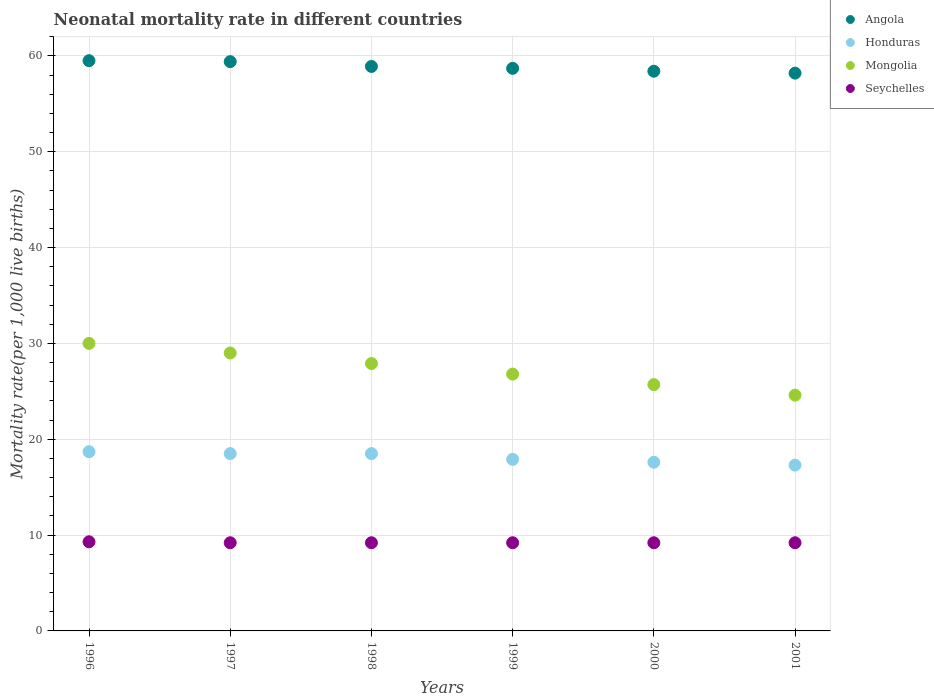What is the neonatal mortality rate in Mongolia in 2001?
Offer a terse response. 24.6. Across all years, what is the maximum neonatal mortality rate in Seychelles?
Give a very brief answer. 9.3. In which year was the neonatal mortality rate in Seychelles minimum?
Your answer should be very brief. 1997. What is the total neonatal mortality rate in Angola in the graph?
Offer a very short reply. 353.1. What is the difference between the neonatal mortality rate in Seychelles in 1996 and that in 1998?
Offer a very short reply. 0.1. What is the average neonatal mortality rate in Angola per year?
Offer a terse response. 58.85. In the year 1996, what is the difference between the neonatal mortality rate in Seychelles and neonatal mortality rate in Honduras?
Make the answer very short. -9.4. In how many years, is the neonatal mortality rate in Honduras greater than 6?
Your response must be concise. 6. What is the ratio of the neonatal mortality rate in Seychelles in 1997 to that in 1998?
Your answer should be very brief. 1. Is the neonatal mortality rate in Angola in 1997 less than that in 2000?
Your answer should be very brief. No. Is the difference between the neonatal mortality rate in Seychelles in 1997 and 1999 greater than the difference between the neonatal mortality rate in Honduras in 1997 and 1999?
Keep it short and to the point. No. What is the difference between the highest and the second highest neonatal mortality rate in Seychelles?
Offer a terse response. 0.1. What is the difference between the highest and the lowest neonatal mortality rate in Honduras?
Your answer should be very brief. 1.4. Is the sum of the neonatal mortality rate in Angola in 1998 and 2000 greater than the maximum neonatal mortality rate in Honduras across all years?
Keep it short and to the point. Yes. Is it the case that in every year, the sum of the neonatal mortality rate in Honduras and neonatal mortality rate in Mongolia  is greater than the sum of neonatal mortality rate in Seychelles and neonatal mortality rate in Angola?
Offer a very short reply. Yes. How many years are there in the graph?
Offer a very short reply. 6. What is the difference between two consecutive major ticks on the Y-axis?
Give a very brief answer. 10. Are the values on the major ticks of Y-axis written in scientific E-notation?
Keep it short and to the point. No. Where does the legend appear in the graph?
Your answer should be very brief. Top right. How many legend labels are there?
Give a very brief answer. 4. How are the legend labels stacked?
Make the answer very short. Vertical. What is the title of the graph?
Your answer should be compact. Neonatal mortality rate in different countries. What is the label or title of the Y-axis?
Your answer should be compact. Mortality rate(per 1,0 live births). What is the Mortality rate(per 1,000 live births) in Angola in 1996?
Provide a short and direct response. 59.5. What is the Mortality rate(per 1,000 live births) of Seychelles in 1996?
Ensure brevity in your answer.  9.3. What is the Mortality rate(per 1,000 live births) in Angola in 1997?
Give a very brief answer. 59.4. What is the Mortality rate(per 1,000 live births) in Honduras in 1997?
Make the answer very short. 18.5. What is the Mortality rate(per 1,000 live births) in Angola in 1998?
Offer a very short reply. 58.9. What is the Mortality rate(per 1,000 live births) of Mongolia in 1998?
Offer a very short reply. 27.9. What is the Mortality rate(per 1,000 live births) of Angola in 1999?
Provide a short and direct response. 58.7. What is the Mortality rate(per 1,000 live births) of Mongolia in 1999?
Your answer should be very brief. 26.8. What is the Mortality rate(per 1,000 live births) of Angola in 2000?
Your response must be concise. 58.4. What is the Mortality rate(per 1,000 live births) of Honduras in 2000?
Offer a terse response. 17.6. What is the Mortality rate(per 1,000 live births) in Mongolia in 2000?
Keep it short and to the point. 25.7. What is the Mortality rate(per 1,000 live births) in Angola in 2001?
Ensure brevity in your answer.  58.2. What is the Mortality rate(per 1,000 live births) in Mongolia in 2001?
Ensure brevity in your answer.  24.6. Across all years, what is the maximum Mortality rate(per 1,000 live births) in Angola?
Make the answer very short. 59.5. Across all years, what is the maximum Mortality rate(per 1,000 live births) of Honduras?
Make the answer very short. 18.7. Across all years, what is the minimum Mortality rate(per 1,000 live births) of Angola?
Offer a terse response. 58.2. Across all years, what is the minimum Mortality rate(per 1,000 live births) in Mongolia?
Provide a short and direct response. 24.6. What is the total Mortality rate(per 1,000 live births) in Angola in the graph?
Provide a succinct answer. 353.1. What is the total Mortality rate(per 1,000 live births) in Honduras in the graph?
Ensure brevity in your answer.  108.5. What is the total Mortality rate(per 1,000 live births) of Mongolia in the graph?
Ensure brevity in your answer.  164. What is the total Mortality rate(per 1,000 live births) in Seychelles in the graph?
Offer a very short reply. 55.3. What is the difference between the Mortality rate(per 1,000 live births) of Honduras in 1996 and that in 1997?
Give a very brief answer. 0.2. What is the difference between the Mortality rate(per 1,000 live births) of Seychelles in 1996 and that in 1997?
Provide a short and direct response. 0.1. What is the difference between the Mortality rate(per 1,000 live births) of Mongolia in 1996 and that in 1998?
Your answer should be very brief. 2.1. What is the difference between the Mortality rate(per 1,000 live births) in Seychelles in 1996 and that in 1998?
Ensure brevity in your answer.  0.1. What is the difference between the Mortality rate(per 1,000 live births) of Seychelles in 1996 and that in 1999?
Provide a short and direct response. 0.1. What is the difference between the Mortality rate(per 1,000 live births) in Honduras in 1996 and that in 2000?
Keep it short and to the point. 1.1. What is the difference between the Mortality rate(per 1,000 live births) of Honduras in 1996 and that in 2001?
Offer a very short reply. 1.4. What is the difference between the Mortality rate(per 1,000 live births) of Mongolia in 1996 and that in 2001?
Provide a short and direct response. 5.4. What is the difference between the Mortality rate(per 1,000 live births) of Mongolia in 1997 and that in 1998?
Ensure brevity in your answer.  1.1. What is the difference between the Mortality rate(per 1,000 live births) of Honduras in 1997 and that in 1999?
Your answer should be very brief. 0.6. What is the difference between the Mortality rate(per 1,000 live births) in Mongolia in 1997 and that in 1999?
Provide a short and direct response. 2.2. What is the difference between the Mortality rate(per 1,000 live births) of Angola in 1997 and that in 2000?
Make the answer very short. 1. What is the difference between the Mortality rate(per 1,000 live births) of Mongolia in 1997 and that in 2000?
Ensure brevity in your answer.  3.3. What is the difference between the Mortality rate(per 1,000 live births) in Angola in 1997 and that in 2001?
Your answer should be compact. 1.2. What is the difference between the Mortality rate(per 1,000 live births) of Mongolia in 1998 and that in 1999?
Offer a terse response. 1.1. What is the difference between the Mortality rate(per 1,000 live births) of Seychelles in 1998 and that in 1999?
Ensure brevity in your answer.  0. What is the difference between the Mortality rate(per 1,000 live births) of Mongolia in 1998 and that in 2000?
Ensure brevity in your answer.  2.2. What is the difference between the Mortality rate(per 1,000 live births) in Honduras in 1998 and that in 2001?
Make the answer very short. 1.2. What is the difference between the Mortality rate(per 1,000 live births) of Mongolia in 1998 and that in 2001?
Keep it short and to the point. 3.3. What is the difference between the Mortality rate(per 1,000 live births) of Seychelles in 1999 and that in 2000?
Ensure brevity in your answer.  0. What is the difference between the Mortality rate(per 1,000 live births) in Angola in 1999 and that in 2001?
Keep it short and to the point. 0.5. What is the difference between the Mortality rate(per 1,000 live births) in Honduras in 1999 and that in 2001?
Make the answer very short. 0.6. What is the difference between the Mortality rate(per 1,000 live births) in Seychelles in 1999 and that in 2001?
Keep it short and to the point. 0. What is the difference between the Mortality rate(per 1,000 live births) of Mongolia in 2000 and that in 2001?
Provide a succinct answer. 1.1. What is the difference between the Mortality rate(per 1,000 live births) in Angola in 1996 and the Mortality rate(per 1,000 live births) in Mongolia in 1997?
Keep it short and to the point. 30.5. What is the difference between the Mortality rate(per 1,000 live births) in Angola in 1996 and the Mortality rate(per 1,000 live births) in Seychelles in 1997?
Make the answer very short. 50.3. What is the difference between the Mortality rate(per 1,000 live births) of Mongolia in 1996 and the Mortality rate(per 1,000 live births) of Seychelles in 1997?
Offer a very short reply. 20.8. What is the difference between the Mortality rate(per 1,000 live births) in Angola in 1996 and the Mortality rate(per 1,000 live births) in Honduras in 1998?
Offer a very short reply. 41. What is the difference between the Mortality rate(per 1,000 live births) of Angola in 1996 and the Mortality rate(per 1,000 live births) of Mongolia in 1998?
Provide a short and direct response. 31.6. What is the difference between the Mortality rate(per 1,000 live births) of Angola in 1996 and the Mortality rate(per 1,000 live births) of Seychelles in 1998?
Provide a short and direct response. 50.3. What is the difference between the Mortality rate(per 1,000 live births) in Honduras in 1996 and the Mortality rate(per 1,000 live births) in Mongolia in 1998?
Your answer should be very brief. -9.2. What is the difference between the Mortality rate(per 1,000 live births) in Honduras in 1996 and the Mortality rate(per 1,000 live births) in Seychelles in 1998?
Your answer should be compact. 9.5. What is the difference between the Mortality rate(per 1,000 live births) in Mongolia in 1996 and the Mortality rate(per 1,000 live births) in Seychelles in 1998?
Offer a very short reply. 20.8. What is the difference between the Mortality rate(per 1,000 live births) in Angola in 1996 and the Mortality rate(per 1,000 live births) in Honduras in 1999?
Your answer should be compact. 41.6. What is the difference between the Mortality rate(per 1,000 live births) in Angola in 1996 and the Mortality rate(per 1,000 live births) in Mongolia in 1999?
Offer a very short reply. 32.7. What is the difference between the Mortality rate(per 1,000 live births) in Angola in 1996 and the Mortality rate(per 1,000 live births) in Seychelles in 1999?
Provide a succinct answer. 50.3. What is the difference between the Mortality rate(per 1,000 live births) of Honduras in 1996 and the Mortality rate(per 1,000 live births) of Mongolia in 1999?
Offer a very short reply. -8.1. What is the difference between the Mortality rate(per 1,000 live births) in Mongolia in 1996 and the Mortality rate(per 1,000 live births) in Seychelles in 1999?
Your answer should be compact. 20.8. What is the difference between the Mortality rate(per 1,000 live births) in Angola in 1996 and the Mortality rate(per 1,000 live births) in Honduras in 2000?
Provide a short and direct response. 41.9. What is the difference between the Mortality rate(per 1,000 live births) in Angola in 1996 and the Mortality rate(per 1,000 live births) in Mongolia in 2000?
Your response must be concise. 33.8. What is the difference between the Mortality rate(per 1,000 live births) of Angola in 1996 and the Mortality rate(per 1,000 live births) of Seychelles in 2000?
Offer a terse response. 50.3. What is the difference between the Mortality rate(per 1,000 live births) of Mongolia in 1996 and the Mortality rate(per 1,000 live births) of Seychelles in 2000?
Make the answer very short. 20.8. What is the difference between the Mortality rate(per 1,000 live births) in Angola in 1996 and the Mortality rate(per 1,000 live births) in Honduras in 2001?
Offer a terse response. 42.2. What is the difference between the Mortality rate(per 1,000 live births) in Angola in 1996 and the Mortality rate(per 1,000 live births) in Mongolia in 2001?
Offer a very short reply. 34.9. What is the difference between the Mortality rate(per 1,000 live births) in Angola in 1996 and the Mortality rate(per 1,000 live births) in Seychelles in 2001?
Give a very brief answer. 50.3. What is the difference between the Mortality rate(per 1,000 live births) in Honduras in 1996 and the Mortality rate(per 1,000 live births) in Seychelles in 2001?
Provide a succinct answer. 9.5. What is the difference between the Mortality rate(per 1,000 live births) of Mongolia in 1996 and the Mortality rate(per 1,000 live births) of Seychelles in 2001?
Provide a succinct answer. 20.8. What is the difference between the Mortality rate(per 1,000 live births) of Angola in 1997 and the Mortality rate(per 1,000 live births) of Honduras in 1998?
Make the answer very short. 40.9. What is the difference between the Mortality rate(per 1,000 live births) of Angola in 1997 and the Mortality rate(per 1,000 live births) of Mongolia in 1998?
Your answer should be very brief. 31.5. What is the difference between the Mortality rate(per 1,000 live births) in Angola in 1997 and the Mortality rate(per 1,000 live births) in Seychelles in 1998?
Your answer should be very brief. 50.2. What is the difference between the Mortality rate(per 1,000 live births) of Honduras in 1997 and the Mortality rate(per 1,000 live births) of Mongolia in 1998?
Give a very brief answer. -9.4. What is the difference between the Mortality rate(per 1,000 live births) of Mongolia in 1997 and the Mortality rate(per 1,000 live births) of Seychelles in 1998?
Ensure brevity in your answer.  19.8. What is the difference between the Mortality rate(per 1,000 live births) of Angola in 1997 and the Mortality rate(per 1,000 live births) of Honduras in 1999?
Your response must be concise. 41.5. What is the difference between the Mortality rate(per 1,000 live births) in Angola in 1997 and the Mortality rate(per 1,000 live births) in Mongolia in 1999?
Your answer should be very brief. 32.6. What is the difference between the Mortality rate(per 1,000 live births) in Angola in 1997 and the Mortality rate(per 1,000 live births) in Seychelles in 1999?
Ensure brevity in your answer.  50.2. What is the difference between the Mortality rate(per 1,000 live births) in Honduras in 1997 and the Mortality rate(per 1,000 live births) in Mongolia in 1999?
Your response must be concise. -8.3. What is the difference between the Mortality rate(per 1,000 live births) in Honduras in 1997 and the Mortality rate(per 1,000 live births) in Seychelles in 1999?
Provide a succinct answer. 9.3. What is the difference between the Mortality rate(per 1,000 live births) in Mongolia in 1997 and the Mortality rate(per 1,000 live births) in Seychelles in 1999?
Provide a succinct answer. 19.8. What is the difference between the Mortality rate(per 1,000 live births) of Angola in 1997 and the Mortality rate(per 1,000 live births) of Honduras in 2000?
Offer a very short reply. 41.8. What is the difference between the Mortality rate(per 1,000 live births) of Angola in 1997 and the Mortality rate(per 1,000 live births) of Mongolia in 2000?
Provide a succinct answer. 33.7. What is the difference between the Mortality rate(per 1,000 live births) in Angola in 1997 and the Mortality rate(per 1,000 live births) in Seychelles in 2000?
Give a very brief answer. 50.2. What is the difference between the Mortality rate(per 1,000 live births) in Mongolia in 1997 and the Mortality rate(per 1,000 live births) in Seychelles in 2000?
Offer a terse response. 19.8. What is the difference between the Mortality rate(per 1,000 live births) in Angola in 1997 and the Mortality rate(per 1,000 live births) in Honduras in 2001?
Provide a short and direct response. 42.1. What is the difference between the Mortality rate(per 1,000 live births) of Angola in 1997 and the Mortality rate(per 1,000 live births) of Mongolia in 2001?
Provide a short and direct response. 34.8. What is the difference between the Mortality rate(per 1,000 live births) of Angola in 1997 and the Mortality rate(per 1,000 live births) of Seychelles in 2001?
Make the answer very short. 50.2. What is the difference between the Mortality rate(per 1,000 live births) of Honduras in 1997 and the Mortality rate(per 1,000 live births) of Mongolia in 2001?
Give a very brief answer. -6.1. What is the difference between the Mortality rate(per 1,000 live births) of Mongolia in 1997 and the Mortality rate(per 1,000 live births) of Seychelles in 2001?
Your answer should be very brief. 19.8. What is the difference between the Mortality rate(per 1,000 live births) in Angola in 1998 and the Mortality rate(per 1,000 live births) in Honduras in 1999?
Give a very brief answer. 41. What is the difference between the Mortality rate(per 1,000 live births) in Angola in 1998 and the Mortality rate(per 1,000 live births) in Mongolia in 1999?
Offer a terse response. 32.1. What is the difference between the Mortality rate(per 1,000 live births) in Angola in 1998 and the Mortality rate(per 1,000 live births) in Seychelles in 1999?
Make the answer very short. 49.7. What is the difference between the Mortality rate(per 1,000 live births) in Honduras in 1998 and the Mortality rate(per 1,000 live births) in Mongolia in 1999?
Ensure brevity in your answer.  -8.3. What is the difference between the Mortality rate(per 1,000 live births) in Honduras in 1998 and the Mortality rate(per 1,000 live births) in Seychelles in 1999?
Offer a terse response. 9.3. What is the difference between the Mortality rate(per 1,000 live births) of Angola in 1998 and the Mortality rate(per 1,000 live births) of Honduras in 2000?
Ensure brevity in your answer.  41.3. What is the difference between the Mortality rate(per 1,000 live births) of Angola in 1998 and the Mortality rate(per 1,000 live births) of Mongolia in 2000?
Ensure brevity in your answer.  33.2. What is the difference between the Mortality rate(per 1,000 live births) of Angola in 1998 and the Mortality rate(per 1,000 live births) of Seychelles in 2000?
Offer a terse response. 49.7. What is the difference between the Mortality rate(per 1,000 live births) in Honduras in 1998 and the Mortality rate(per 1,000 live births) in Seychelles in 2000?
Offer a terse response. 9.3. What is the difference between the Mortality rate(per 1,000 live births) of Mongolia in 1998 and the Mortality rate(per 1,000 live births) of Seychelles in 2000?
Ensure brevity in your answer.  18.7. What is the difference between the Mortality rate(per 1,000 live births) in Angola in 1998 and the Mortality rate(per 1,000 live births) in Honduras in 2001?
Ensure brevity in your answer.  41.6. What is the difference between the Mortality rate(per 1,000 live births) in Angola in 1998 and the Mortality rate(per 1,000 live births) in Mongolia in 2001?
Your response must be concise. 34.3. What is the difference between the Mortality rate(per 1,000 live births) of Angola in 1998 and the Mortality rate(per 1,000 live births) of Seychelles in 2001?
Make the answer very short. 49.7. What is the difference between the Mortality rate(per 1,000 live births) in Honduras in 1998 and the Mortality rate(per 1,000 live births) in Mongolia in 2001?
Offer a terse response. -6.1. What is the difference between the Mortality rate(per 1,000 live births) in Honduras in 1998 and the Mortality rate(per 1,000 live births) in Seychelles in 2001?
Provide a short and direct response. 9.3. What is the difference between the Mortality rate(per 1,000 live births) of Mongolia in 1998 and the Mortality rate(per 1,000 live births) of Seychelles in 2001?
Your answer should be very brief. 18.7. What is the difference between the Mortality rate(per 1,000 live births) in Angola in 1999 and the Mortality rate(per 1,000 live births) in Honduras in 2000?
Your answer should be very brief. 41.1. What is the difference between the Mortality rate(per 1,000 live births) of Angola in 1999 and the Mortality rate(per 1,000 live births) of Mongolia in 2000?
Provide a succinct answer. 33. What is the difference between the Mortality rate(per 1,000 live births) of Angola in 1999 and the Mortality rate(per 1,000 live births) of Seychelles in 2000?
Your answer should be very brief. 49.5. What is the difference between the Mortality rate(per 1,000 live births) of Honduras in 1999 and the Mortality rate(per 1,000 live births) of Mongolia in 2000?
Give a very brief answer. -7.8. What is the difference between the Mortality rate(per 1,000 live births) in Honduras in 1999 and the Mortality rate(per 1,000 live births) in Seychelles in 2000?
Offer a terse response. 8.7. What is the difference between the Mortality rate(per 1,000 live births) in Angola in 1999 and the Mortality rate(per 1,000 live births) in Honduras in 2001?
Give a very brief answer. 41.4. What is the difference between the Mortality rate(per 1,000 live births) in Angola in 1999 and the Mortality rate(per 1,000 live births) in Mongolia in 2001?
Offer a very short reply. 34.1. What is the difference between the Mortality rate(per 1,000 live births) in Angola in 1999 and the Mortality rate(per 1,000 live births) in Seychelles in 2001?
Provide a short and direct response. 49.5. What is the difference between the Mortality rate(per 1,000 live births) in Angola in 2000 and the Mortality rate(per 1,000 live births) in Honduras in 2001?
Offer a terse response. 41.1. What is the difference between the Mortality rate(per 1,000 live births) of Angola in 2000 and the Mortality rate(per 1,000 live births) of Mongolia in 2001?
Offer a very short reply. 33.8. What is the difference between the Mortality rate(per 1,000 live births) of Angola in 2000 and the Mortality rate(per 1,000 live births) of Seychelles in 2001?
Make the answer very short. 49.2. What is the difference between the Mortality rate(per 1,000 live births) in Honduras in 2000 and the Mortality rate(per 1,000 live births) in Mongolia in 2001?
Keep it short and to the point. -7. What is the difference between the Mortality rate(per 1,000 live births) in Honduras in 2000 and the Mortality rate(per 1,000 live births) in Seychelles in 2001?
Give a very brief answer. 8.4. What is the difference between the Mortality rate(per 1,000 live births) of Mongolia in 2000 and the Mortality rate(per 1,000 live births) of Seychelles in 2001?
Ensure brevity in your answer.  16.5. What is the average Mortality rate(per 1,000 live births) of Angola per year?
Your answer should be very brief. 58.85. What is the average Mortality rate(per 1,000 live births) in Honduras per year?
Your answer should be compact. 18.08. What is the average Mortality rate(per 1,000 live births) of Mongolia per year?
Offer a terse response. 27.33. What is the average Mortality rate(per 1,000 live births) in Seychelles per year?
Your answer should be compact. 9.22. In the year 1996, what is the difference between the Mortality rate(per 1,000 live births) of Angola and Mortality rate(per 1,000 live births) of Honduras?
Offer a terse response. 40.8. In the year 1996, what is the difference between the Mortality rate(per 1,000 live births) in Angola and Mortality rate(per 1,000 live births) in Mongolia?
Your response must be concise. 29.5. In the year 1996, what is the difference between the Mortality rate(per 1,000 live births) in Angola and Mortality rate(per 1,000 live births) in Seychelles?
Ensure brevity in your answer.  50.2. In the year 1996, what is the difference between the Mortality rate(per 1,000 live births) of Honduras and Mortality rate(per 1,000 live births) of Mongolia?
Provide a succinct answer. -11.3. In the year 1996, what is the difference between the Mortality rate(per 1,000 live births) in Honduras and Mortality rate(per 1,000 live births) in Seychelles?
Make the answer very short. 9.4. In the year 1996, what is the difference between the Mortality rate(per 1,000 live births) in Mongolia and Mortality rate(per 1,000 live births) in Seychelles?
Give a very brief answer. 20.7. In the year 1997, what is the difference between the Mortality rate(per 1,000 live births) of Angola and Mortality rate(per 1,000 live births) of Honduras?
Provide a short and direct response. 40.9. In the year 1997, what is the difference between the Mortality rate(per 1,000 live births) in Angola and Mortality rate(per 1,000 live births) in Mongolia?
Your response must be concise. 30.4. In the year 1997, what is the difference between the Mortality rate(per 1,000 live births) in Angola and Mortality rate(per 1,000 live births) in Seychelles?
Keep it short and to the point. 50.2. In the year 1997, what is the difference between the Mortality rate(per 1,000 live births) of Honduras and Mortality rate(per 1,000 live births) of Mongolia?
Provide a succinct answer. -10.5. In the year 1997, what is the difference between the Mortality rate(per 1,000 live births) in Mongolia and Mortality rate(per 1,000 live births) in Seychelles?
Your response must be concise. 19.8. In the year 1998, what is the difference between the Mortality rate(per 1,000 live births) in Angola and Mortality rate(per 1,000 live births) in Honduras?
Make the answer very short. 40.4. In the year 1998, what is the difference between the Mortality rate(per 1,000 live births) of Angola and Mortality rate(per 1,000 live births) of Mongolia?
Make the answer very short. 31. In the year 1998, what is the difference between the Mortality rate(per 1,000 live births) in Angola and Mortality rate(per 1,000 live births) in Seychelles?
Offer a very short reply. 49.7. In the year 1998, what is the difference between the Mortality rate(per 1,000 live births) of Honduras and Mortality rate(per 1,000 live births) of Seychelles?
Make the answer very short. 9.3. In the year 1999, what is the difference between the Mortality rate(per 1,000 live births) in Angola and Mortality rate(per 1,000 live births) in Honduras?
Provide a succinct answer. 40.8. In the year 1999, what is the difference between the Mortality rate(per 1,000 live births) of Angola and Mortality rate(per 1,000 live births) of Mongolia?
Your answer should be very brief. 31.9. In the year 1999, what is the difference between the Mortality rate(per 1,000 live births) in Angola and Mortality rate(per 1,000 live births) in Seychelles?
Provide a succinct answer. 49.5. In the year 1999, what is the difference between the Mortality rate(per 1,000 live births) in Honduras and Mortality rate(per 1,000 live births) in Mongolia?
Offer a terse response. -8.9. In the year 1999, what is the difference between the Mortality rate(per 1,000 live births) in Honduras and Mortality rate(per 1,000 live births) in Seychelles?
Keep it short and to the point. 8.7. In the year 2000, what is the difference between the Mortality rate(per 1,000 live births) in Angola and Mortality rate(per 1,000 live births) in Honduras?
Make the answer very short. 40.8. In the year 2000, what is the difference between the Mortality rate(per 1,000 live births) of Angola and Mortality rate(per 1,000 live births) of Mongolia?
Your answer should be very brief. 32.7. In the year 2000, what is the difference between the Mortality rate(per 1,000 live births) in Angola and Mortality rate(per 1,000 live births) in Seychelles?
Provide a short and direct response. 49.2. In the year 2000, what is the difference between the Mortality rate(per 1,000 live births) of Honduras and Mortality rate(per 1,000 live births) of Mongolia?
Provide a succinct answer. -8.1. In the year 2000, what is the difference between the Mortality rate(per 1,000 live births) of Mongolia and Mortality rate(per 1,000 live births) of Seychelles?
Give a very brief answer. 16.5. In the year 2001, what is the difference between the Mortality rate(per 1,000 live births) of Angola and Mortality rate(per 1,000 live births) of Honduras?
Your answer should be compact. 40.9. In the year 2001, what is the difference between the Mortality rate(per 1,000 live births) in Angola and Mortality rate(per 1,000 live births) in Mongolia?
Keep it short and to the point. 33.6. In the year 2001, what is the difference between the Mortality rate(per 1,000 live births) of Angola and Mortality rate(per 1,000 live births) of Seychelles?
Your answer should be compact. 49. In the year 2001, what is the difference between the Mortality rate(per 1,000 live births) in Honduras and Mortality rate(per 1,000 live births) in Mongolia?
Keep it short and to the point. -7.3. What is the ratio of the Mortality rate(per 1,000 live births) in Angola in 1996 to that in 1997?
Your answer should be very brief. 1. What is the ratio of the Mortality rate(per 1,000 live births) in Honduras in 1996 to that in 1997?
Your answer should be very brief. 1.01. What is the ratio of the Mortality rate(per 1,000 live births) in Mongolia in 1996 to that in 1997?
Give a very brief answer. 1.03. What is the ratio of the Mortality rate(per 1,000 live births) of Seychelles in 1996 to that in 1997?
Make the answer very short. 1.01. What is the ratio of the Mortality rate(per 1,000 live births) of Angola in 1996 to that in 1998?
Your answer should be compact. 1.01. What is the ratio of the Mortality rate(per 1,000 live births) of Honduras in 1996 to that in 1998?
Provide a short and direct response. 1.01. What is the ratio of the Mortality rate(per 1,000 live births) of Mongolia in 1996 to that in 1998?
Offer a very short reply. 1.08. What is the ratio of the Mortality rate(per 1,000 live births) of Seychelles in 1996 to that in 1998?
Offer a very short reply. 1.01. What is the ratio of the Mortality rate(per 1,000 live births) of Angola in 1996 to that in 1999?
Provide a succinct answer. 1.01. What is the ratio of the Mortality rate(per 1,000 live births) in Honduras in 1996 to that in 1999?
Give a very brief answer. 1.04. What is the ratio of the Mortality rate(per 1,000 live births) of Mongolia in 1996 to that in 1999?
Give a very brief answer. 1.12. What is the ratio of the Mortality rate(per 1,000 live births) in Seychelles in 1996 to that in 1999?
Your answer should be compact. 1.01. What is the ratio of the Mortality rate(per 1,000 live births) of Angola in 1996 to that in 2000?
Offer a terse response. 1.02. What is the ratio of the Mortality rate(per 1,000 live births) in Mongolia in 1996 to that in 2000?
Your answer should be compact. 1.17. What is the ratio of the Mortality rate(per 1,000 live births) in Seychelles in 1996 to that in 2000?
Your answer should be compact. 1.01. What is the ratio of the Mortality rate(per 1,000 live births) in Angola in 1996 to that in 2001?
Keep it short and to the point. 1.02. What is the ratio of the Mortality rate(per 1,000 live births) of Honduras in 1996 to that in 2001?
Keep it short and to the point. 1.08. What is the ratio of the Mortality rate(per 1,000 live births) of Mongolia in 1996 to that in 2001?
Your answer should be compact. 1.22. What is the ratio of the Mortality rate(per 1,000 live births) of Seychelles in 1996 to that in 2001?
Give a very brief answer. 1.01. What is the ratio of the Mortality rate(per 1,000 live births) of Angola in 1997 to that in 1998?
Your answer should be very brief. 1.01. What is the ratio of the Mortality rate(per 1,000 live births) of Mongolia in 1997 to that in 1998?
Offer a terse response. 1.04. What is the ratio of the Mortality rate(per 1,000 live births) of Angola in 1997 to that in 1999?
Your response must be concise. 1.01. What is the ratio of the Mortality rate(per 1,000 live births) in Honduras in 1997 to that in 1999?
Keep it short and to the point. 1.03. What is the ratio of the Mortality rate(per 1,000 live births) of Mongolia in 1997 to that in 1999?
Provide a short and direct response. 1.08. What is the ratio of the Mortality rate(per 1,000 live births) of Angola in 1997 to that in 2000?
Offer a very short reply. 1.02. What is the ratio of the Mortality rate(per 1,000 live births) of Honduras in 1997 to that in 2000?
Make the answer very short. 1.05. What is the ratio of the Mortality rate(per 1,000 live births) of Mongolia in 1997 to that in 2000?
Your answer should be compact. 1.13. What is the ratio of the Mortality rate(per 1,000 live births) of Angola in 1997 to that in 2001?
Make the answer very short. 1.02. What is the ratio of the Mortality rate(per 1,000 live births) in Honduras in 1997 to that in 2001?
Provide a succinct answer. 1.07. What is the ratio of the Mortality rate(per 1,000 live births) in Mongolia in 1997 to that in 2001?
Offer a very short reply. 1.18. What is the ratio of the Mortality rate(per 1,000 live births) in Angola in 1998 to that in 1999?
Your answer should be compact. 1. What is the ratio of the Mortality rate(per 1,000 live births) of Honduras in 1998 to that in 1999?
Provide a succinct answer. 1.03. What is the ratio of the Mortality rate(per 1,000 live births) in Mongolia in 1998 to that in 1999?
Make the answer very short. 1.04. What is the ratio of the Mortality rate(per 1,000 live births) in Seychelles in 1998 to that in 1999?
Give a very brief answer. 1. What is the ratio of the Mortality rate(per 1,000 live births) of Angola in 1998 to that in 2000?
Give a very brief answer. 1.01. What is the ratio of the Mortality rate(per 1,000 live births) in Honduras in 1998 to that in 2000?
Offer a very short reply. 1.05. What is the ratio of the Mortality rate(per 1,000 live births) of Mongolia in 1998 to that in 2000?
Give a very brief answer. 1.09. What is the ratio of the Mortality rate(per 1,000 live births) in Seychelles in 1998 to that in 2000?
Offer a very short reply. 1. What is the ratio of the Mortality rate(per 1,000 live births) in Honduras in 1998 to that in 2001?
Keep it short and to the point. 1.07. What is the ratio of the Mortality rate(per 1,000 live births) in Mongolia in 1998 to that in 2001?
Provide a short and direct response. 1.13. What is the ratio of the Mortality rate(per 1,000 live births) in Seychelles in 1998 to that in 2001?
Keep it short and to the point. 1. What is the ratio of the Mortality rate(per 1,000 live births) of Honduras in 1999 to that in 2000?
Your response must be concise. 1.02. What is the ratio of the Mortality rate(per 1,000 live births) in Mongolia in 1999 to that in 2000?
Offer a terse response. 1.04. What is the ratio of the Mortality rate(per 1,000 live births) of Angola in 1999 to that in 2001?
Your answer should be very brief. 1.01. What is the ratio of the Mortality rate(per 1,000 live births) in Honduras in 1999 to that in 2001?
Provide a short and direct response. 1.03. What is the ratio of the Mortality rate(per 1,000 live births) of Mongolia in 1999 to that in 2001?
Offer a terse response. 1.09. What is the ratio of the Mortality rate(per 1,000 live births) of Angola in 2000 to that in 2001?
Make the answer very short. 1. What is the ratio of the Mortality rate(per 1,000 live births) of Honduras in 2000 to that in 2001?
Your response must be concise. 1.02. What is the ratio of the Mortality rate(per 1,000 live births) in Mongolia in 2000 to that in 2001?
Provide a succinct answer. 1.04. What is the difference between the highest and the second highest Mortality rate(per 1,000 live births) in Honduras?
Offer a very short reply. 0.2. What is the difference between the highest and the second highest Mortality rate(per 1,000 live births) of Mongolia?
Give a very brief answer. 1. What is the difference between the highest and the second highest Mortality rate(per 1,000 live births) in Seychelles?
Offer a terse response. 0.1. What is the difference between the highest and the lowest Mortality rate(per 1,000 live births) in Angola?
Your response must be concise. 1.3. What is the difference between the highest and the lowest Mortality rate(per 1,000 live births) in Mongolia?
Provide a succinct answer. 5.4. 